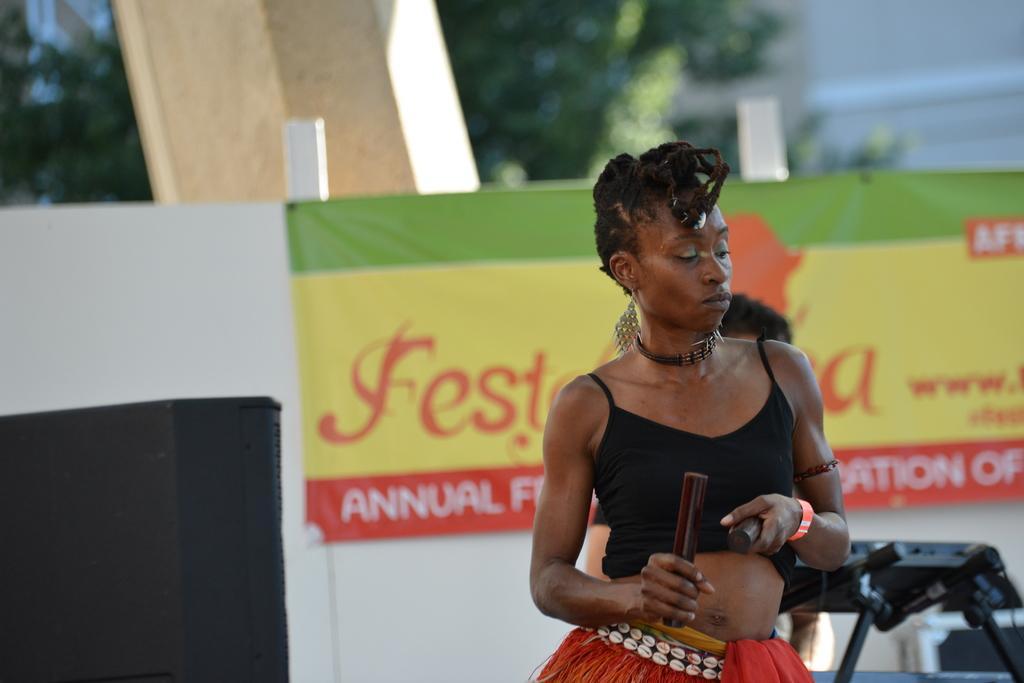In one or two sentences, can you explain what this image depicts? On the right side, there is a woman in a black color t-shirt, holding two sticks with both hands. In the background, there is another person, there is a keyboard on a stand, there is a banner, there are trees, a wall and other objects. And the background is blurred. 